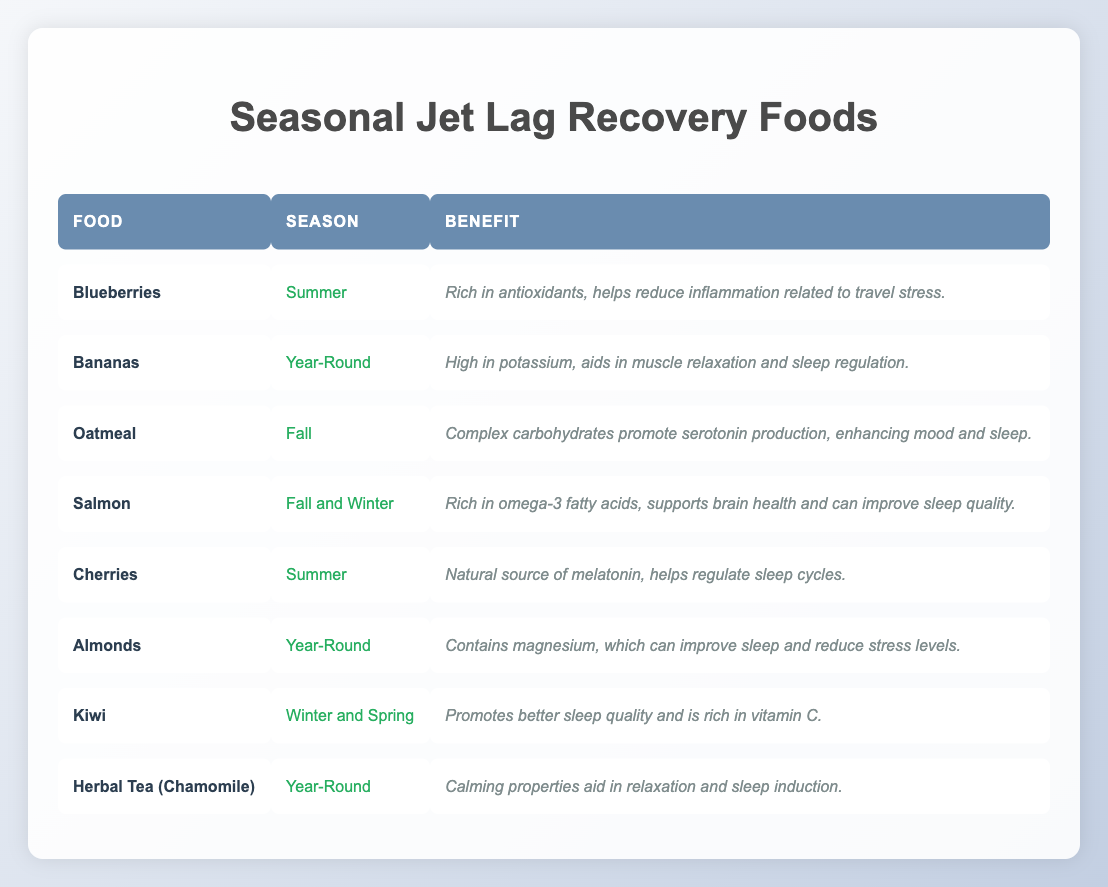What seasonal food is known for helping regulate sleep cycles? Cherries are mentioned in the table as a natural source of melatonin, which helps regulate sleep cycles. According to the season column, cherries are available in the summer.
Answer: Cherries Which food is rich in omega-3 fatty acids and supports brain health? The table lists salmon, which is rich in omega-3 fatty acids, as well as its benefits for brain health and sleep quality. It is available in both fall and winter.
Answer: Salmon Are bananas available year-round? The table clearly states that bananas are labeled as year-round, confirming their availability throughout the year.
Answer: Yes How many foods are listed for the winter season? To find this, we count the foods that have "Winter" in the season column. Only Kiwi and Salmon are associated with winter, leading to a total of two foods.
Answer: 2 Which food has the benefit of promoting serotonin production? Oatmeal is identified in the table for its complex carbohydrates that promote serotonin production, and it is labeled as a fall food.
Answer: Oatmeal Is there any food in the table that helps reduce inflammation related to travel stress? According to the table, blueberries are specifically noted for being rich in antioxidants that help reduce inflammation. This indicates that blueberries fulfill this benefit.
Answer: Yes What are the benefits of eating almonds according to the table? The table states that almonds contain magnesium, which can improve sleep and reduce stress levels, providing a clear benefit.
Answer: Contains magnesium for sleep and stress reduction Which food should be considered for the spring season and what is its benefit? Kiwi is marked for its availability in winter and spring. Its benefits include promoting better sleep quality and being rich in vitamin C. This indicates that kiwi can be a suitable food during spring.
Answer: Kiwi; better sleep quality and rich in vitamin C How many foods listed help with relaxation and sleep induction? By reviewing the benefits column, herbal tea (chamomile) is noted for its calming properties that aid relaxation and sleep induction, while almonds can also contribute to stress reduction which promotes relaxation. This gives us a total of two foods.
Answer: 2 